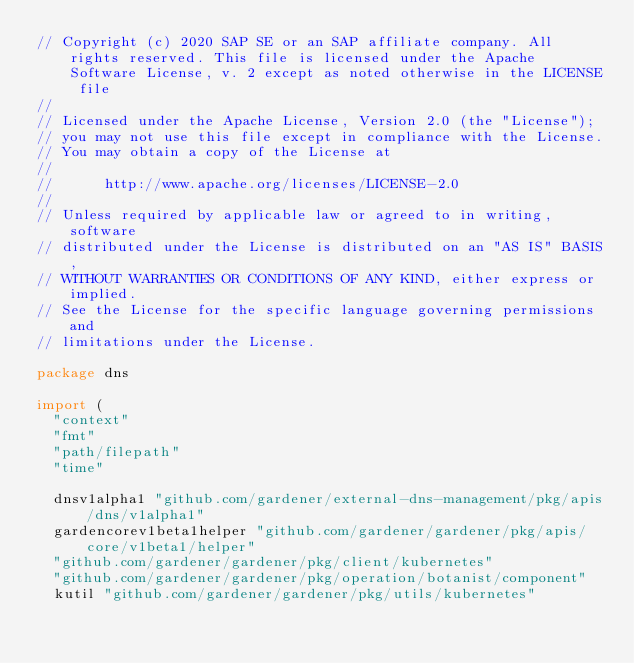<code> <loc_0><loc_0><loc_500><loc_500><_Go_>// Copyright (c) 2020 SAP SE or an SAP affiliate company. All rights reserved. This file is licensed under the Apache Software License, v. 2 except as noted otherwise in the LICENSE file
//
// Licensed under the Apache License, Version 2.0 (the "License");
// you may not use this file except in compliance with the License.
// You may obtain a copy of the License at
//
//      http://www.apache.org/licenses/LICENSE-2.0
//
// Unless required by applicable law or agreed to in writing, software
// distributed under the License is distributed on an "AS IS" BASIS,
// WITHOUT WARRANTIES OR CONDITIONS OF ANY KIND, either express or implied.
// See the License for the specific language governing permissions and
// limitations under the License.

package dns

import (
	"context"
	"fmt"
	"path/filepath"
	"time"

	dnsv1alpha1 "github.com/gardener/external-dns-management/pkg/apis/dns/v1alpha1"
	gardencorev1beta1helper "github.com/gardener/gardener/pkg/apis/core/v1beta1/helper"
	"github.com/gardener/gardener/pkg/client/kubernetes"
	"github.com/gardener/gardener/pkg/operation/botanist/component"
	kutil "github.com/gardener/gardener/pkg/utils/kubernetes"</code> 